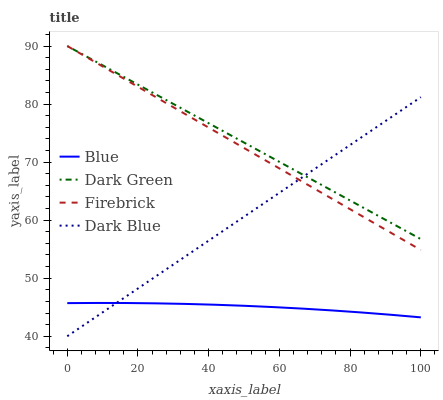Does Blue have the minimum area under the curve?
Answer yes or no. Yes. Does Dark Green have the maximum area under the curve?
Answer yes or no. Yes. Does Dark Blue have the minimum area under the curve?
Answer yes or no. No. Does Dark Blue have the maximum area under the curve?
Answer yes or no. No. Is Firebrick the smoothest?
Answer yes or no. Yes. Is Blue the roughest?
Answer yes or no. Yes. Is Dark Blue the smoothest?
Answer yes or no. No. Is Dark Blue the roughest?
Answer yes or no. No. Does Dark Blue have the lowest value?
Answer yes or no. Yes. Does Firebrick have the lowest value?
Answer yes or no. No. Does Dark Green have the highest value?
Answer yes or no. Yes. Does Dark Blue have the highest value?
Answer yes or no. No. Is Blue less than Dark Green?
Answer yes or no. Yes. Is Firebrick greater than Blue?
Answer yes or no. Yes. Does Dark Blue intersect Blue?
Answer yes or no. Yes. Is Dark Blue less than Blue?
Answer yes or no. No. Is Dark Blue greater than Blue?
Answer yes or no. No. Does Blue intersect Dark Green?
Answer yes or no. No. 